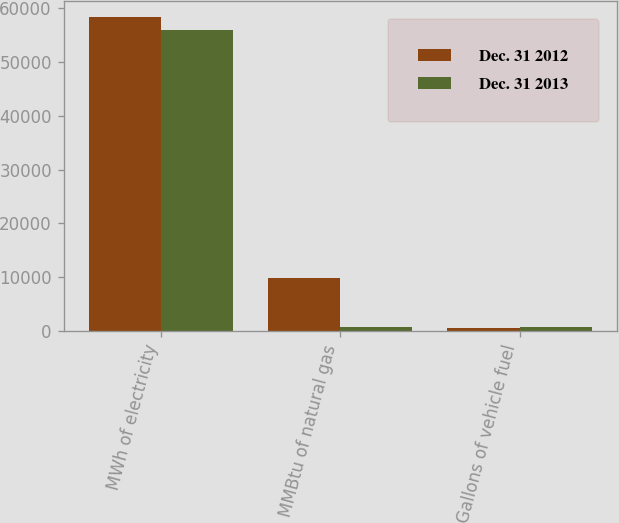<chart> <loc_0><loc_0><loc_500><loc_500><stacked_bar_chart><ecel><fcel>MWh of electricity<fcel>MMBtu of natural gas<fcel>Gallons of vehicle fuel<nl><fcel>Dec. 31 2012<fcel>58423<fcel>9854<fcel>482<nl><fcel>Dec. 31 2013<fcel>55976<fcel>725<fcel>682<nl></chart> 